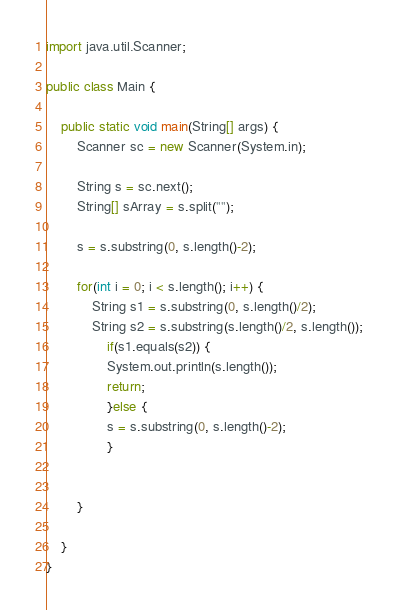Convert code to text. <code><loc_0><loc_0><loc_500><loc_500><_Java_>import java.util.Scanner;

public class Main {

	public static void main(String[] args) {
		Scanner sc = new Scanner(System.in);
		
		String s = sc.next();
		String[] sArray = s.split("");
		
		s = s.substring(0, s.length()-2);
		
		for(int i = 0; i < s.length(); i++) {
			String s1 = s.substring(0, s.length()/2);
			String s2 = s.substring(s.length()/2, s.length());
				if(s1.equals(s2)) {
				System.out.println(s.length());
				return;	
				}else {
		    	s = s.substring(0, s.length()-2);
				} 
		 

		}

	}
}
</code> 